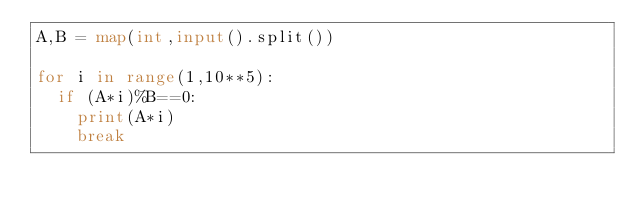<code> <loc_0><loc_0><loc_500><loc_500><_Python_>A,B = map(int,input().split())

for i in range(1,10**5):
  if (A*i)%B==0:
    print(A*i)
    break</code> 